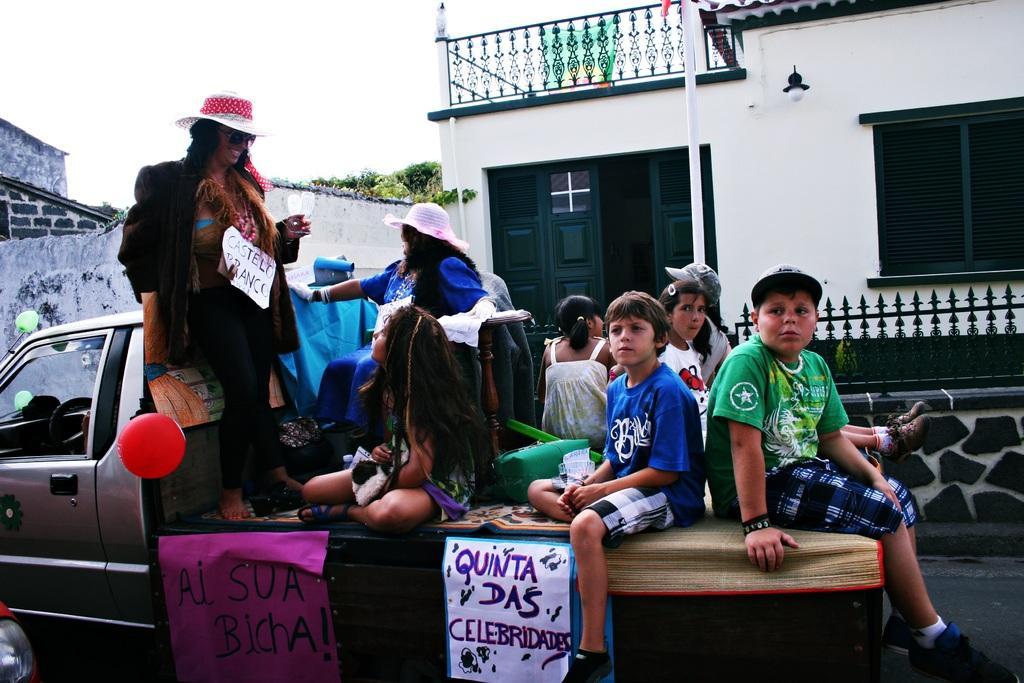Describe this image in one or two sentences. The picture is taken outside of the house on the road where one vehicle is present, in the vehicle there are people sitting and one woman is standing and wearing a hat and there are some charts on which the text is written and behind them there is a big house and trees. 